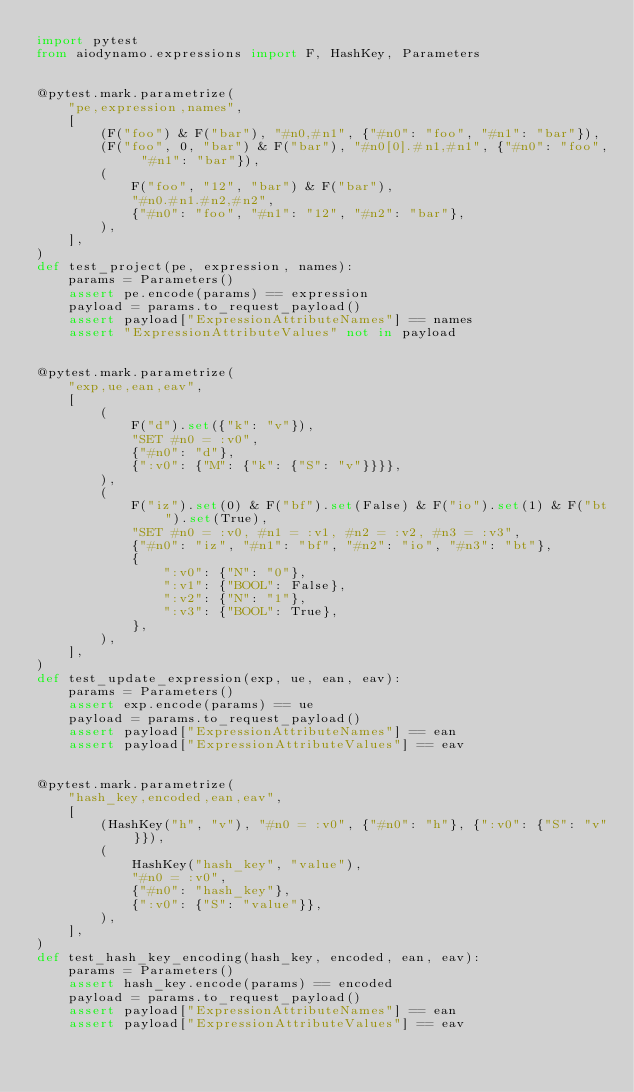<code> <loc_0><loc_0><loc_500><loc_500><_Python_>import pytest
from aiodynamo.expressions import F, HashKey, Parameters


@pytest.mark.parametrize(
    "pe,expression,names",
    [
        (F("foo") & F("bar"), "#n0,#n1", {"#n0": "foo", "#n1": "bar"}),
        (F("foo", 0, "bar") & F("bar"), "#n0[0].#n1,#n1", {"#n0": "foo", "#n1": "bar"}),
        (
            F("foo", "12", "bar") & F("bar"),
            "#n0.#n1.#n2,#n2",
            {"#n0": "foo", "#n1": "12", "#n2": "bar"},
        ),
    ],
)
def test_project(pe, expression, names):
    params = Parameters()
    assert pe.encode(params) == expression
    payload = params.to_request_payload()
    assert payload["ExpressionAttributeNames"] == names
    assert "ExpressionAttributeValues" not in payload


@pytest.mark.parametrize(
    "exp,ue,ean,eav",
    [
        (
            F("d").set({"k": "v"}),
            "SET #n0 = :v0",
            {"#n0": "d"},
            {":v0": {"M": {"k": {"S": "v"}}}},
        ),
        (
            F("iz").set(0) & F("bf").set(False) & F("io").set(1) & F("bt").set(True),
            "SET #n0 = :v0, #n1 = :v1, #n2 = :v2, #n3 = :v3",
            {"#n0": "iz", "#n1": "bf", "#n2": "io", "#n3": "bt"},
            {
                ":v0": {"N": "0"},
                ":v1": {"BOOL": False},
                ":v2": {"N": "1"},
                ":v3": {"BOOL": True},
            },
        ),
    ],
)
def test_update_expression(exp, ue, ean, eav):
    params = Parameters()
    assert exp.encode(params) == ue
    payload = params.to_request_payload()
    assert payload["ExpressionAttributeNames"] == ean
    assert payload["ExpressionAttributeValues"] == eav


@pytest.mark.parametrize(
    "hash_key,encoded,ean,eav",
    [
        (HashKey("h", "v"), "#n0 = :v0", {"#n0": "h"}, {":v0": {"S": "v"}}),
        (
            HashKey("hash_key", "value"),
            "#n0 = :v0",
            {"#n0": "hash_key"},
            {":v0": {"S": "value"}},
        ),
    ],
)
def test_hash_key_encoding(hash_key, encoded, ean, eav):
    params = Parameters()
    assert hash_key.encode(params) == encoded
    payload = params.to_request_payload()
    assert payload["ExpressionAttributeNames"] == ean
    assert payload["ExpressionAttributeValues"] == eav
</code> 